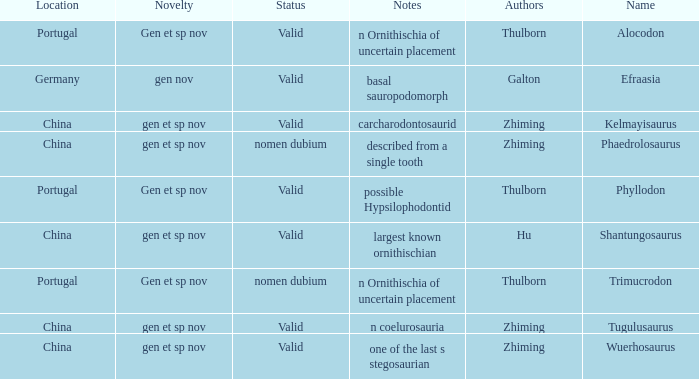What is the Novelty of the dinosaur that was named by the Author, Zhiming, and whose Notes are, "carcharodontosaurid"? Gen et sp nov. 